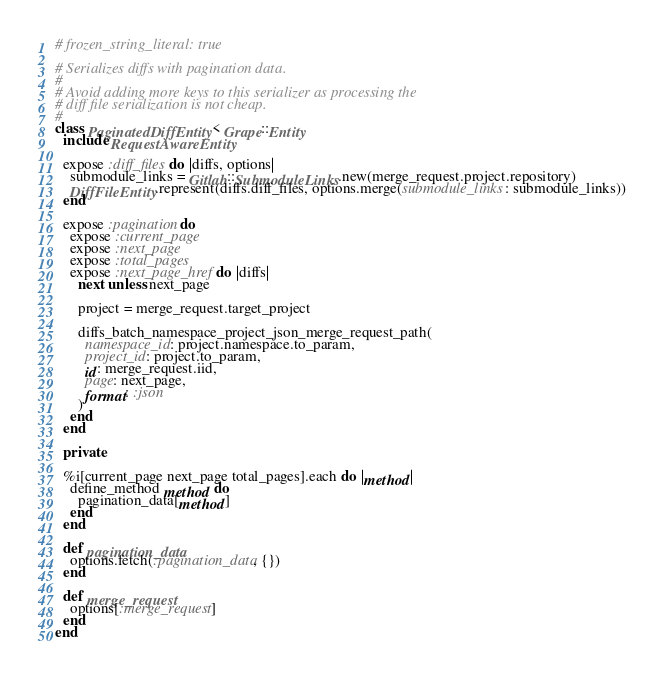Convert code to text. <code><loc_0><loc_0><loc_500><loc_500><_Ruby_># frozen_string_literal: true

# Serializes diffs with pagination data.
#
# Avoid adding more keys to this serializer as processing the
# diff file serialization is not cheap.
#
class PaginatedDiffEntity < Grape::Entity
  include RequestAwareEntity

  expose :diff_files do |diffs, options|
    submodule_links = Gitlab::SubmoduleLinks.new(merge_request.project.repository)
    DiffFileEntity.represent(diffs.diff_files, options.merge(submodule_links: submodule_links))
  end

  expose :pagination do
    expose :current_page
    expose :next_page
    expose :total_pages
    expose :next_page_href do |diffs|
      next unless next_page

      project = merge_request.target_project

      diffs_batch_namespace_project_json_merge_request_path(
        namespace_id: project.namespace.to_param,
        project_id: project.to_param,
        id: merge_request.iid,
        page: next_page,
        format: :json
      )
    end
  end

  private

  %i[current_page next_page total_pages].each do |method|
    define_method method do
      pagination_data[method]
    end
  end

  def pagination_data
    options.fetch(:pagination_data, {})
  end

  def merge_request
    options[:merge_request]
  end
end
</code> 